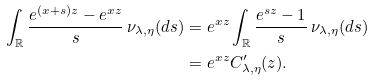Convert formula to latex. <formula><loc_0><loc_0><loc_500><loc_500>\int _ { \mathbb { R } } \frac { e ^ { ( x + s ) z } - e ^ { x z } } { s } \, \nu _ { \lambda , \eta } ( d s ) & = e ^ { x z } \int _ { \mathbb { R } } \frac { e ^ { s z } - 1 } { s } \, \nu _ { \lambda , \eta } ( d s ) \\ & = e ^ { x z } C ^ { \prime } _ { \lambda , \eta } ( z ) .</formula> 